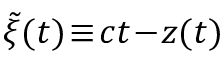Convert formula to latex. <formula><loc_0><loc_0><loc_500><loc_500>\tilde { \xi } ( t ) \, \equiv \, c t \, - \, z ( t )</formula> 